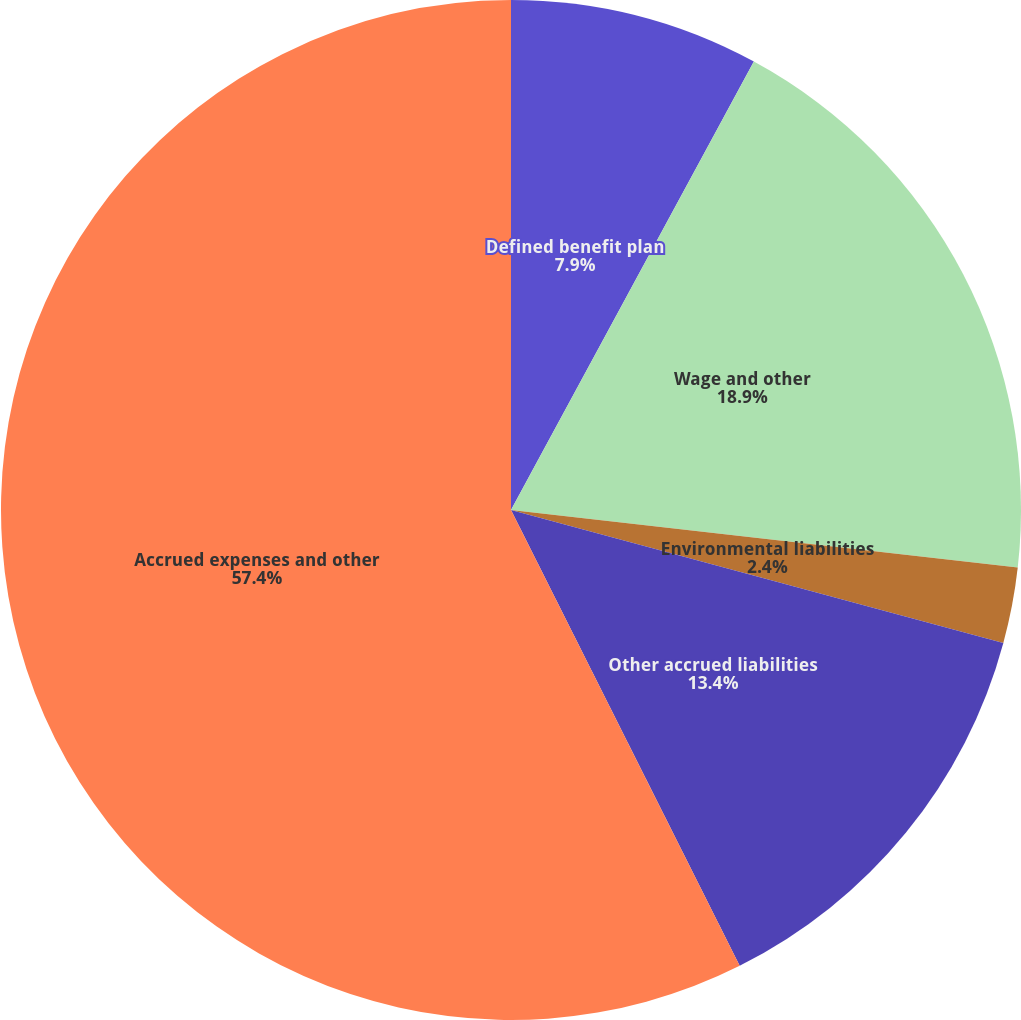Convert chart to OTSL. <chart><loc_0><loc_0><loc_500><loc_500><pie_chart><fcel>Defined benefit plan<fcel>Wage and other<fcel>Environmental liabilities<fcel>Other accrued liabilities<fcel>Accrued expenses and other<nl><fcel>7.9%<fcel>18.9%<fcel>2.4%<fcel>13.4%<fcel>57.4%<nl></chart> 